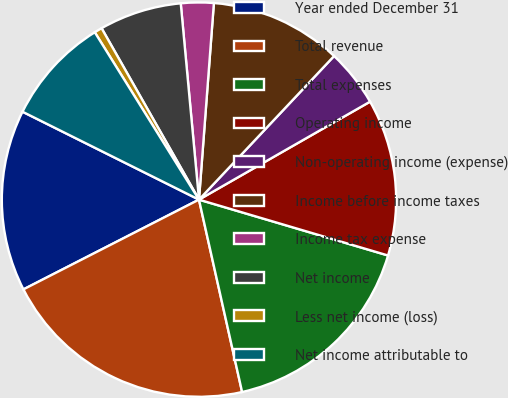Convert chart. <chart><loc_0><loc_0><loc_500><loc_500><pie_chart><fcel>Year ended December 31<fcel>Total revenue<fcel>Total expenses<fcel>Operating income<fcel>Non-operating income (expense)<fcel>Income before income taxes<fcel>Income tax expense<fcel>Net income<fcel>Less net income (loss)<fcel>Net income attributable to<nl><fcel>14.88%<fcel>20.99%<fcel>16.92%<fcel>12.85%<fcel>4.71%<fcel>10.81%<fcel>2.68%<fcel>6.75%<fcel>0.64%<fcel>8.78%<nl></chart> 